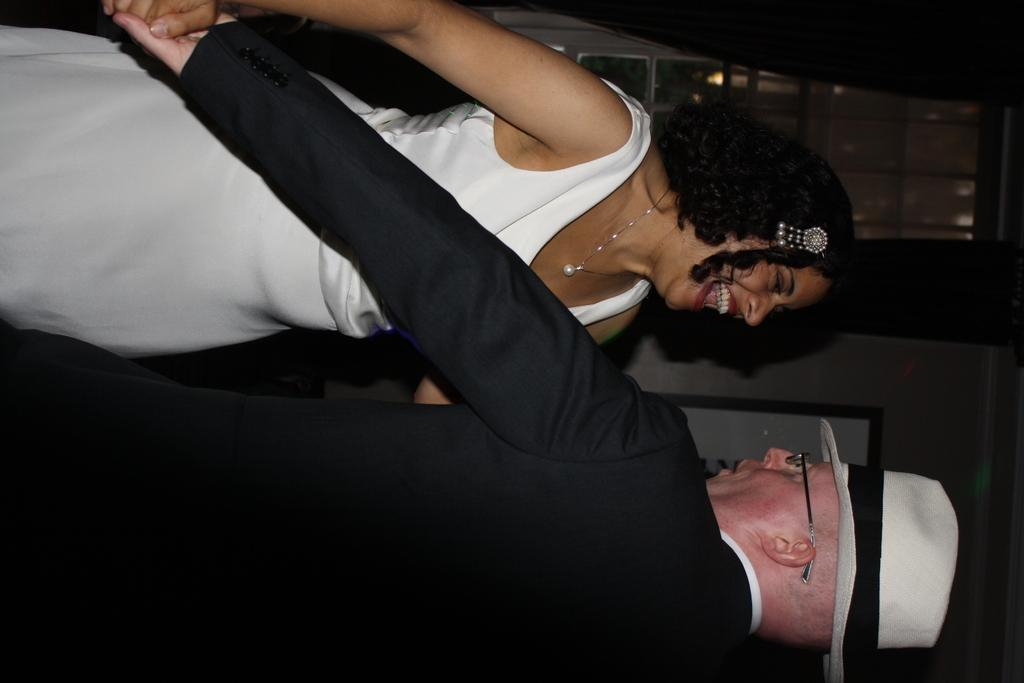What is the main subject of the picture? The main subject of the picture is a man. Can you describe the man's attire? The man is wearing a hat. What is the man doing in the picture? The man is holding a woman's hand. How are the man and woman positioned in relation to each other? The woman is standing in front of the man. What type of quartz can be seen in the man's pocket in the image? There is no quartz visible in the image, and the man's pocket is not mentioned in the provided facts. Can you describe the gate that the man and woman are standing next to in the image? There is no gate present in the image; it only features the man, the woman, and their respective positions. 